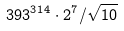Convert formula to latex. <formula><loc_0><loc_0><loc_500><loc_500>3 9 3 ^ { 3 1 4 } \cdot 2 ^ { 7 } / \sqrt { 1 0 }</formula> 